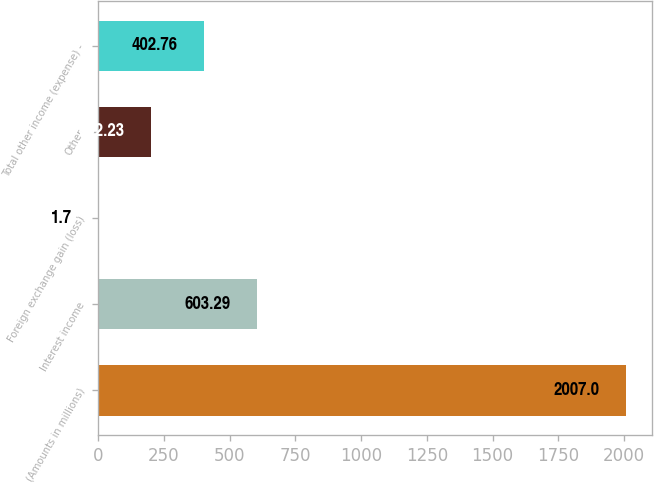Convert chart to OTSL. <chart><loc_0><loc_0><loc_500><loc_500><bar_chart><fcel>(Amounts in millions)<fcel>Interest income<fcel>Foreign exchange gain (loss)<fcel>Other<fcel>Total other income (expense) -<nl><fcel>2007<fcel>603.29<fcel>1.7<fcel>202.23<fcel>402.76<nl></chart> 